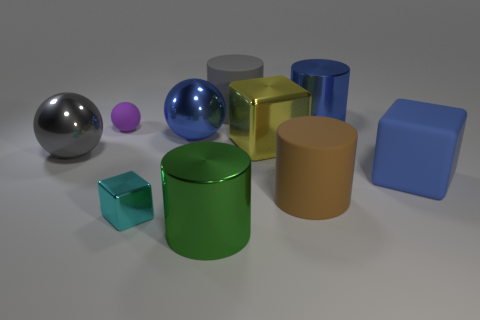Subtract all cylinders. How many objects are left? 6 Add 9 tiny gray rubber cylinders. How many tiny gray rubber cylinders exist? 9 Subtract 1 blue cubes. How many objects are left? 9 Subtract all small gray cubes. Subtract all big gray cylinders. How many objects are left? 9 Add 5 big gray cylinders. How many big gray cylinders are left? 6 